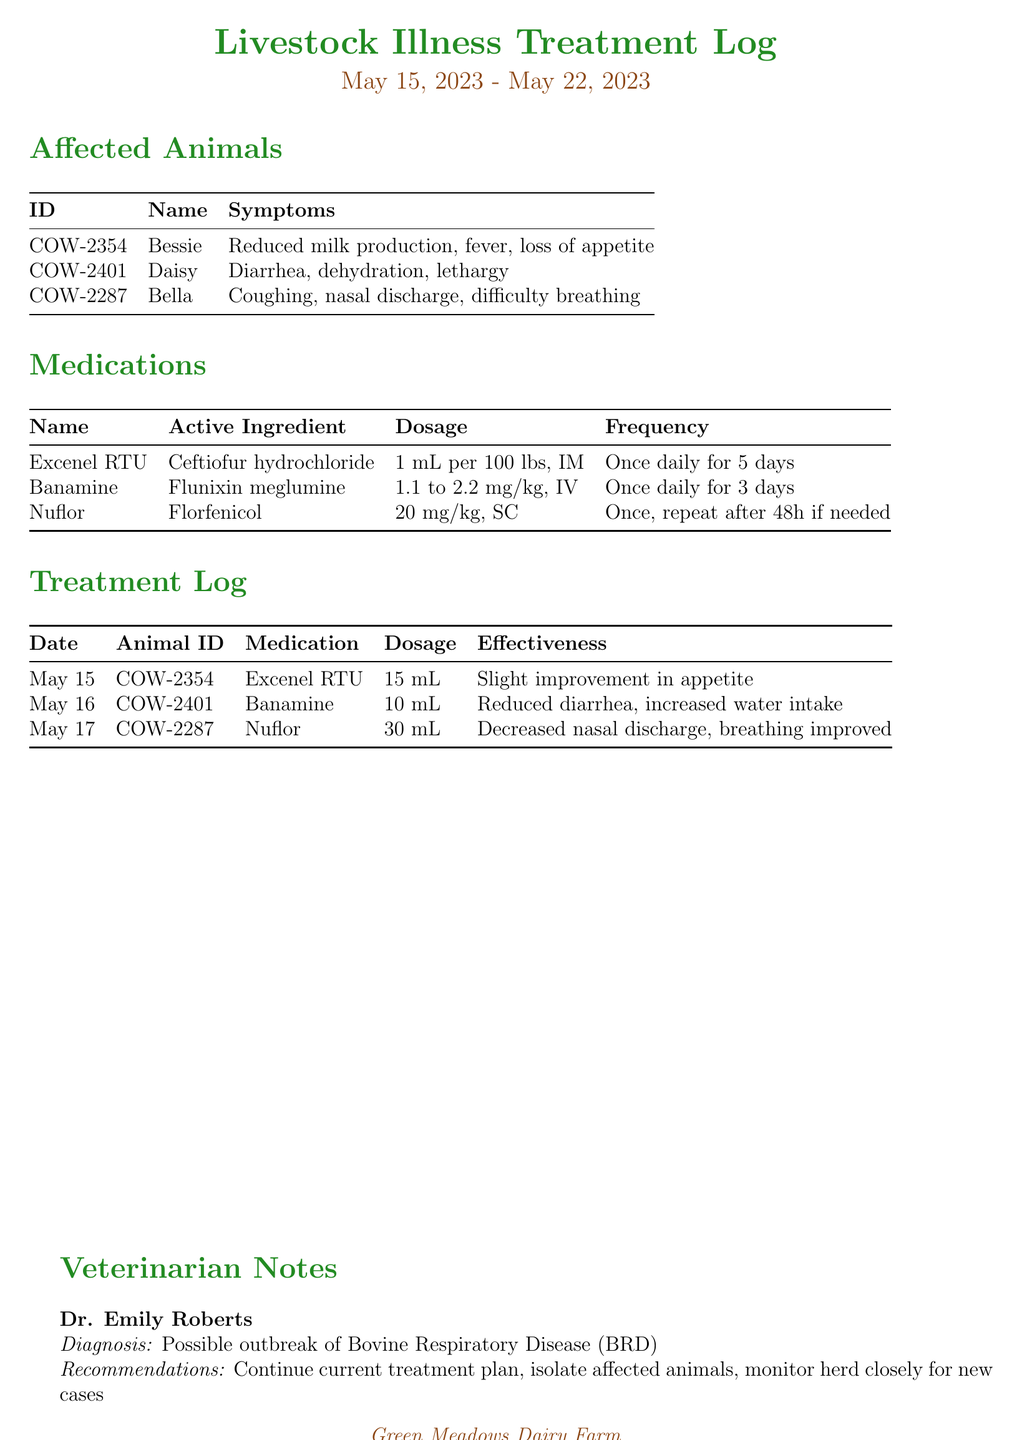What is the name of the farm? The farm name is listed in the document's header section, indicating the farm's identity.
Answer: Green Meadows Dairy Farm Who is the farmer? The farmer's name is provided in the document's header, showcasing the main person responsible for the farm.
Answer: John Thompson What is the illness suspected in the livestock? The veterinarian notes indicate the diagnosis expected based on the symptoms presented in the affected animals.
Answer: Bovine Respiratory Disease (BRD) What medication was given to Bessie? The treatment log specifies which medication was administered to each affected animal on certain dates.
Answer: Excenel RTU What dosage of Banamine was given on May 16? The treatment log specifies the exact dosage given to Daisy on that date.
Answer: 10 mL Which animal exhibited coughing and nasal discharge? The affected animals section describes the conditions of each animal, highlighting the symptoms they experienced.
Answer: Bella How many days was Excenel RTU administered? The medications section outlines the frequency of the treatment, indicating how often it should be given.
Answer: Once daily for 5 days What was the effectiveness of Nuflor treatment? The treatment log records the effectiveness observed after administering the medication to Bella.
Answer: Decreased nasal discharge, breathing improved 